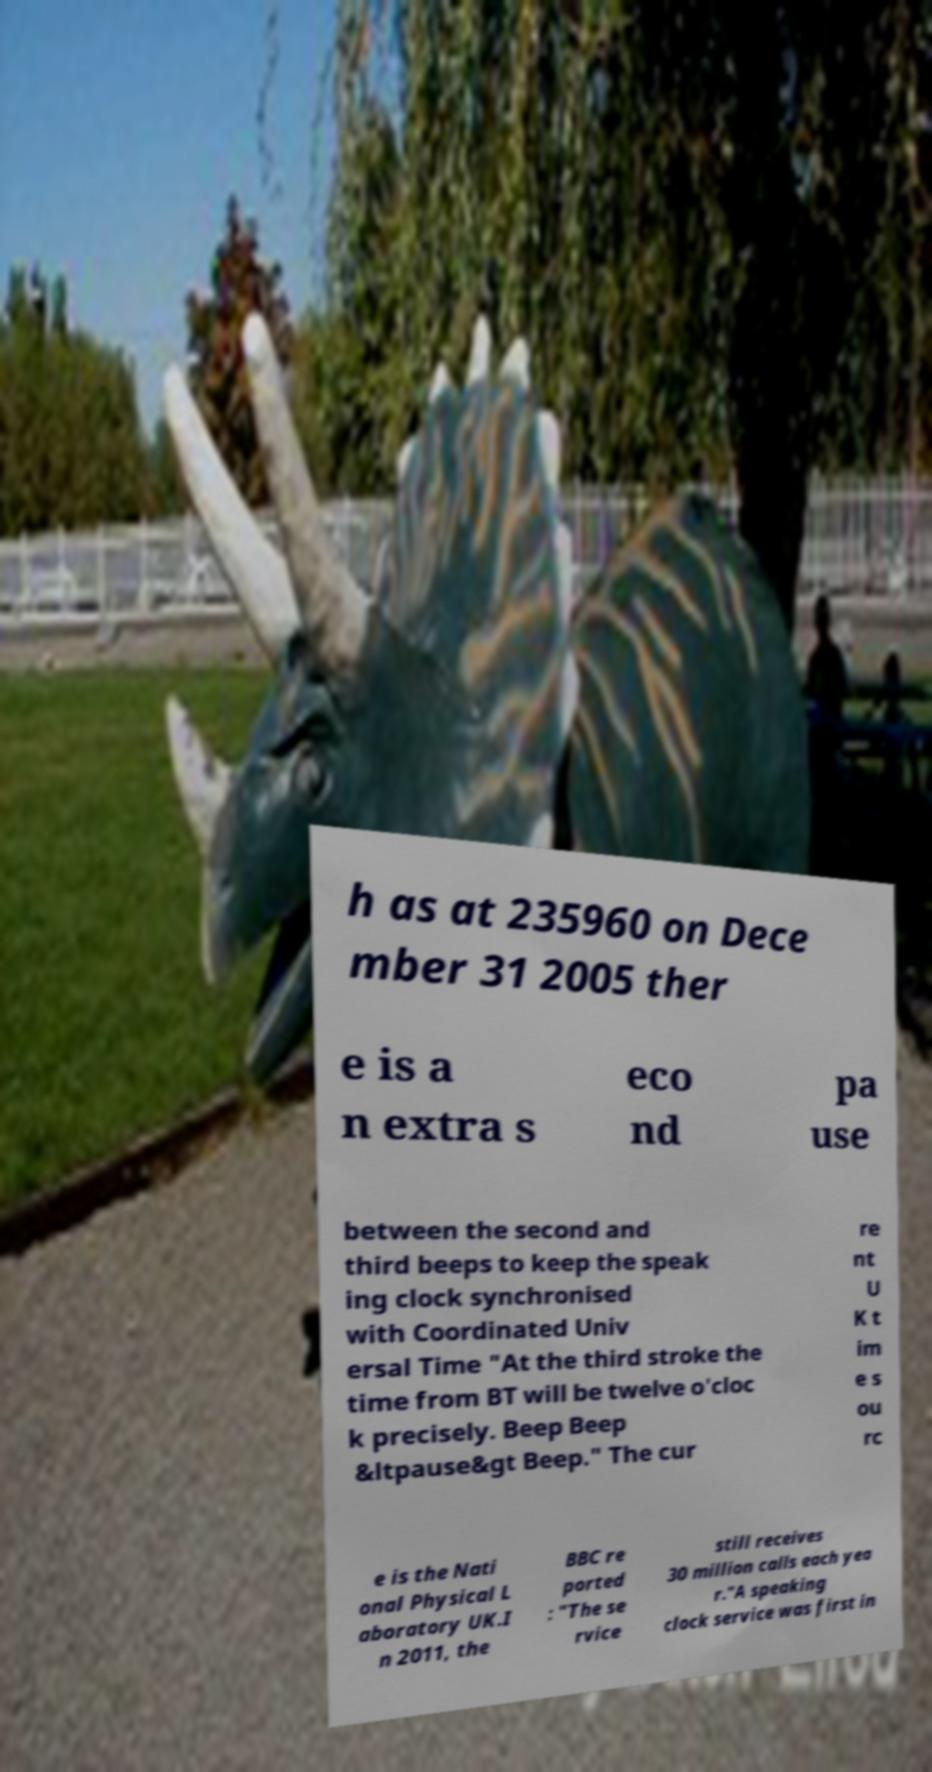Please identify and transcribe the text found in this image. h as at 235960 on Dece mber 31 2005 ther e is a n extra s eco nd pa use between the second and third beeps to keep the speak ing clock synchronised with Coordinated Univ ersal Time "At the third stroke the time from BT will be twelve o'cloc k precisely. Beep Beep &ltpause&gt Beep." The cur re nt U K t im e s ou rc e is the Nati onal Physical L aboratory UK.I n 2011, the BBC re ported : "The se rvice still receives 30 million calls each yea r."A speaking clock service was first in 